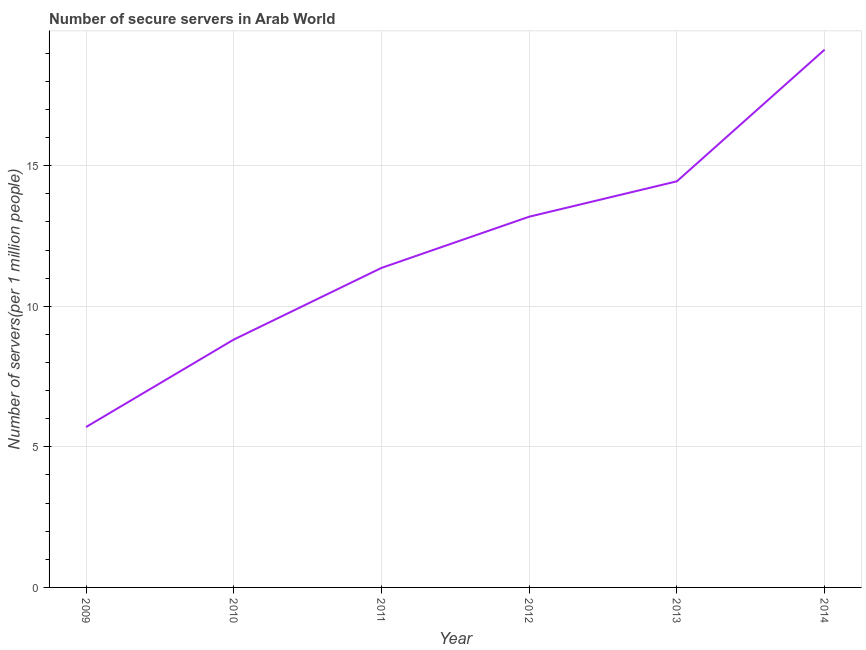What is the number of secure internet servers in 2011?
Provide a succinct answer. 11.36. Across all years, what is the maximum number of secure internet servers?
Provide a succinct answer. 19.13. Across all years, what is the minimum number of secure internet servers?
Offer a terse response. 5.71. What is the sum of the number of secure internet servers?
Your answer should be very brief. 72.64. What is the difference between the number of secure internet servers in 2011 and 2014?
Keep it short and to the point. -7.76. What is the average number of secure internet servers per year?
Give a very brief answer. 12.11. What is the median number of secure internet servers?
Provide a short and direct response. 12.27. What is the ratio of the number of secure internet servers in 2013 to that in 2014?
Keep it short and to the point. 0.76. What is the difference between the highest and the second highest number of secure internet servers?
Offer a very short reply. 4.68. What is the difference between the highest and the lowest number of secure internet servers?
Give a very brief answer. 13.42. Does the number of secure internet servers monotonically increase over the years?
Make the answer very short. Yes. What is the difference between two consecutive major ticks on the Y-axis?
Offer a very short reply. 5. Are the values on the major ticks of Y-axis written in scientific E-notation?
Make the answer very short. No. What is the title of the graph?
Your answer should be very brief. Number of secure servers in Arab World. What is the label or title of the X-axis?
Offer a terse response. Year. What is the label or title of the Y-axis?
Your response must be concise. Number of servers(per 1 million people). What is the Number of servers(per 1 million people) in 2009?
Provide a succinct answer. 5.71. What is the Number of servers(per 1 million people) in 2010?
Your answer should be very brief. 8.82. What is the Number of servers(per 1 million people) in 2011?
Give a very brief answer. 11.36. What is the Number of servers(per 1 million people) in 2012?
Your answer should be compact. 13.19. What is the Number of servers(per 1 million people) of 2013?
Provide a succinct answer. 14.44. What is the Number of servers(per 1 million people) of 2014?
Make the answer very short. 19.13. What is the difference between the Number of servers(per 1 million people) in 2009 and 2010?
Your answer should be compact. -3.11. What is the difference between the Number of servers(per 1 million people) in 2009 and 2011?
Make the answer very short. -5.66. What is the difference between the Number of servers(per 1 million people) in 2009 and 2012?
Give a very brief answer. -7.48. What is the difference between the Number of servers(per 1 million people) in 2009 and 2013?
Your answer should be very brief. -8.74. What is the difference between the Number of servers(per 1 million people) in 2009 and 2014?
Offer a terse response. -13.42. What is the difference between the Number of servers(per 1 million people) in 2010 and 2011?
Provide a short and direct response. -2.55. What is the difference between the Number of servers(per 1 million people) in 2010 and 2012?
Ensure brevity in your answer.  -4.37. What is the difference between the Number of servers(per 1 million people) in 2010 and 2013?
Provide a short and direct response. -5.63. What is the difference between the Number of servers(per 1 million people) in 2010 and 2014?
Ensure brevity in your answer.  -10.31. What is the difference between the Number of servers(per 1 million people) in 2011 and 2012?
Offer a very short reply. -1.82. What is the difference between the Number of servers(per 1 million people) in 2011 and 2013?
Your response must be concise. -3.08. What is the difference between the Number of servers(per 1 million people) in 2011 and 2014?
Give a very brief answer. -7.76. What is the difference between the Number of servers(per 1 million people) in 2012 and 2013?
Offer a terse response. -1.26. What is the difference between the Number of servers(per 1 million people) in 2012 and 2014?
Give a very brief answer. -5.94. What is the difference between the Number of servers(per 1 million people) in 2013 and 2014?
Offer a terse response. -4.68. What is the ratio of the Number of servers(per 1 million people) in 2009 to that in 2010?
Provide a succinct answer. 0.65. What is the ratio of the Number of servers(per 1 million people) in 2009 to that in 2011?
Your answer should be compact. 0.5. What is the ratio of the Number of servers(per 1 million people) in 2009 to that in 2012?
Give a very brief answer. 0.43. What is the ratio of the Number of servers(per 1 million people) in 2009 to that in 2013?
Offer a very short reply. 0.4. What is the ratio of the Number of servers(per 1 million people) in 2009 to that in 2014?
Your answer should be very brief. 0.3. What is the ratio of the Number of servers(per 1 million people) in 2010 to that in 2011?
Give a very brief answer. 0.78. What is the ratio of the Number of servers(per 1 million people) in 2010 to that in 2012?
Provide a succinct answer. 0.67. What is the ratio of the Number of servers(per 1 million people) in 2010 to that in 2013?
Your response must be concise. 0.61. What is the ratio of the Number of servers(per 1 million people) in 2010 to that in 2014?
Ensure brevity in your answer.  0.46. What is the ratio of the Number of servers(per 1 million people) in 2011 to that in 2012?
Keep it short and to the point. 0.86. What is the ratio of the Number of servers(per 1 million people) in 2011 to that in 2013?
Your response must be concise. 0.79. What is the ratio of the Number of servers(per 1 million people) in 2011 to that in 2014?
Offer a very short reply. 0.59. What is the ratio of the Number of servers(per 1 million people) in 2012 to that in 2014?
Offer a terse response. 0.69. What is the ratio of the Number of servers(per 1 million people) in 2013 to that in 2014?
Give a very brief answer. 0.76. 